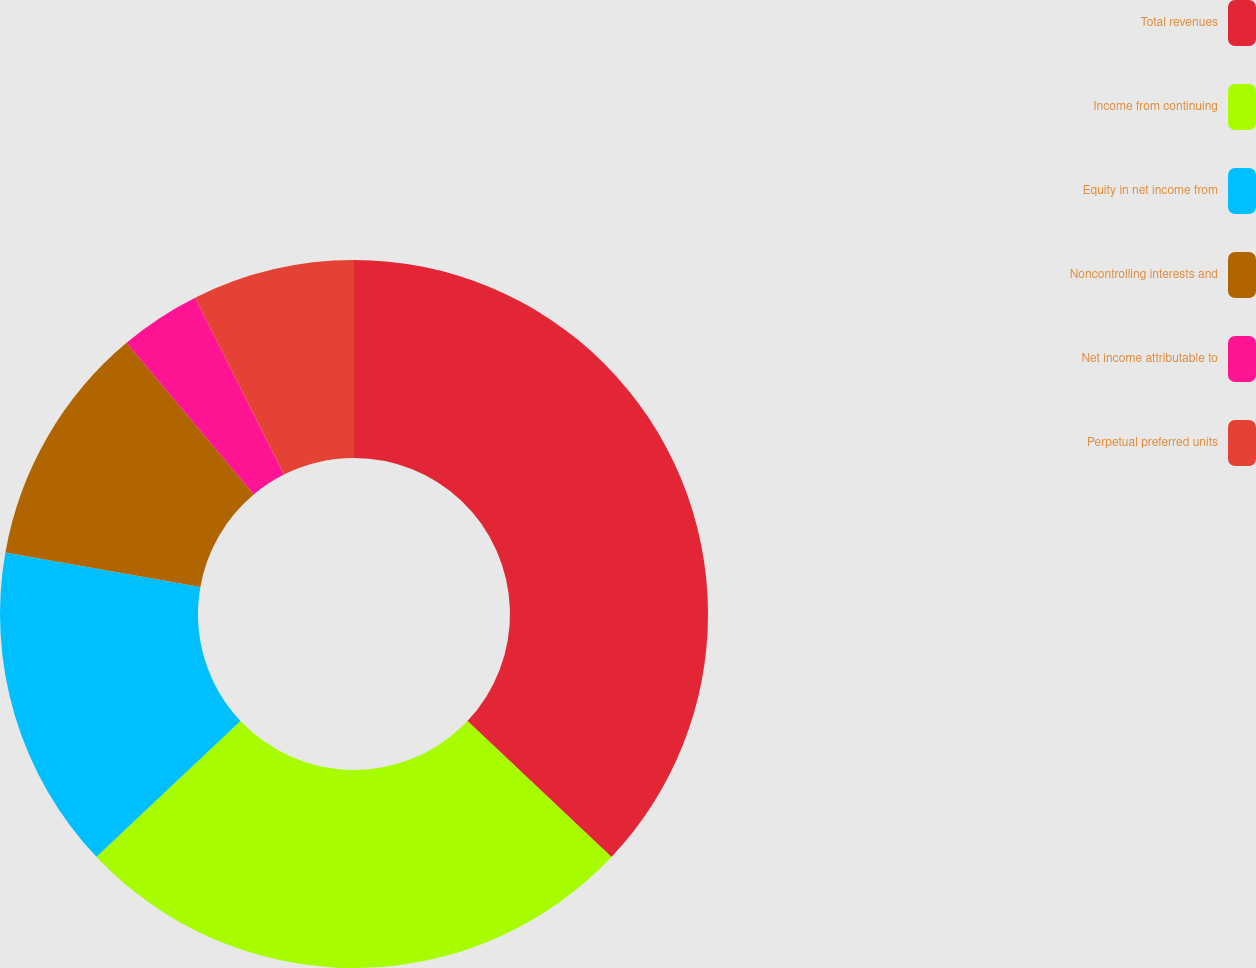Convert chart. <chart><loc_0><loc_0><loc_500><loc_500><pie_chart><fcel>Total revenues<fcel>Income from continuing<fcel>Equity in net income from<fcel>Noncontrolling interests and<fcel>Net income attributable to<fcel>Perpetual preferred units<nl><fcel>37.04%<fcel>25.93%<fcel>14.81%<fcel>11.11%<fcel>3.7%<fcel>7.41%<nl></chart> 